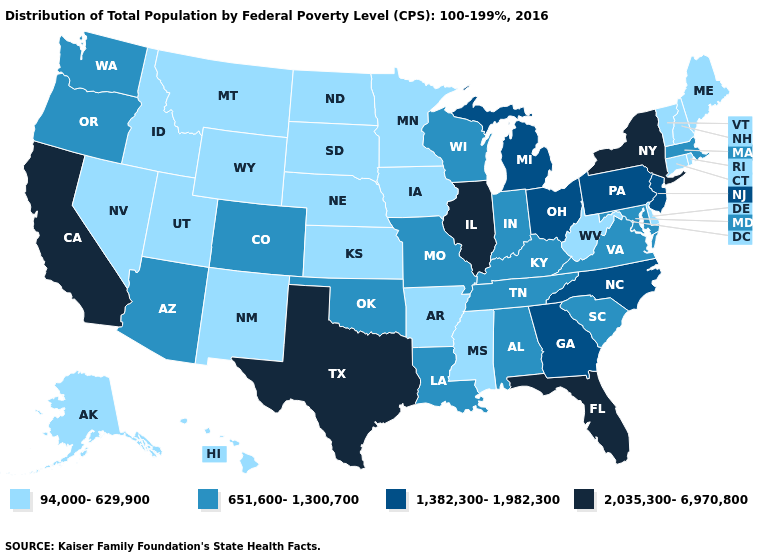Does South Carolina have a lower value than Connecticut?
Give a very brief answer. No. What is the highest value in states that border Wyoming?
Keep it brief. 651,600-1,300,700. Does Ohio have the highest value in the USA?
Concise answer only. No. Name the states that have a value in the range 2,035,300-6,970,800?
Be succinct. California, Florida, Illinois, New York, Texas. What is the lowest value in the MidWest?
Keep it brief. 94,000-629,900. Name the states that have a value in the range 94,000-629,900?
Concise answer only. Alaska, Arkansas, Connecticut, Delaware, Hawaii, Idaho, Iowa, Kansas, Maine, Minnesota, Mississippi, Montana, Nebraska, Nevada, New Hampshire, New Mexico, North Dakota, Rhode Island, South Dakota, Utah, Vermont, West Virginia, Wyoming. What is the lowest value in states that border Wyoming?
Quick response, please. 94,000-629,900. Among the states that border North Carolina , which have the lowest value?
Write a very short answer. South Carolina, Tennessee, Virginia. What is the lowest value in the USA?
Keep it brief. 94,000-629,900. What is the value of Nevada?
Concise answer only. 94,000-629,900. Which states have the lowest value in the USA?
Quick response, please. Alaska, Arkansas, Connecticut, Delaware, Hawaii, Idaho, Iowa, Kansas, Maine, Minnesota, Mississippi, Montana, Nebraska, Nevada, New Hampshire, New Mexico, North Dakota, Rhode Island, South Dakota, Utah, Vermont, West Virginia, Wyoming. Among the states that border Illinois , does Iowa have the highest value?
Short answer required. No. What is the value of Mississippi?
Answer briefly. 94,000-629,900. What is the lowest value in the Northeast?
Short answer required. 94,000-629,900. What is the value of New Jersey?
Give a very brief answer. 1,382,300-1,982,300. 